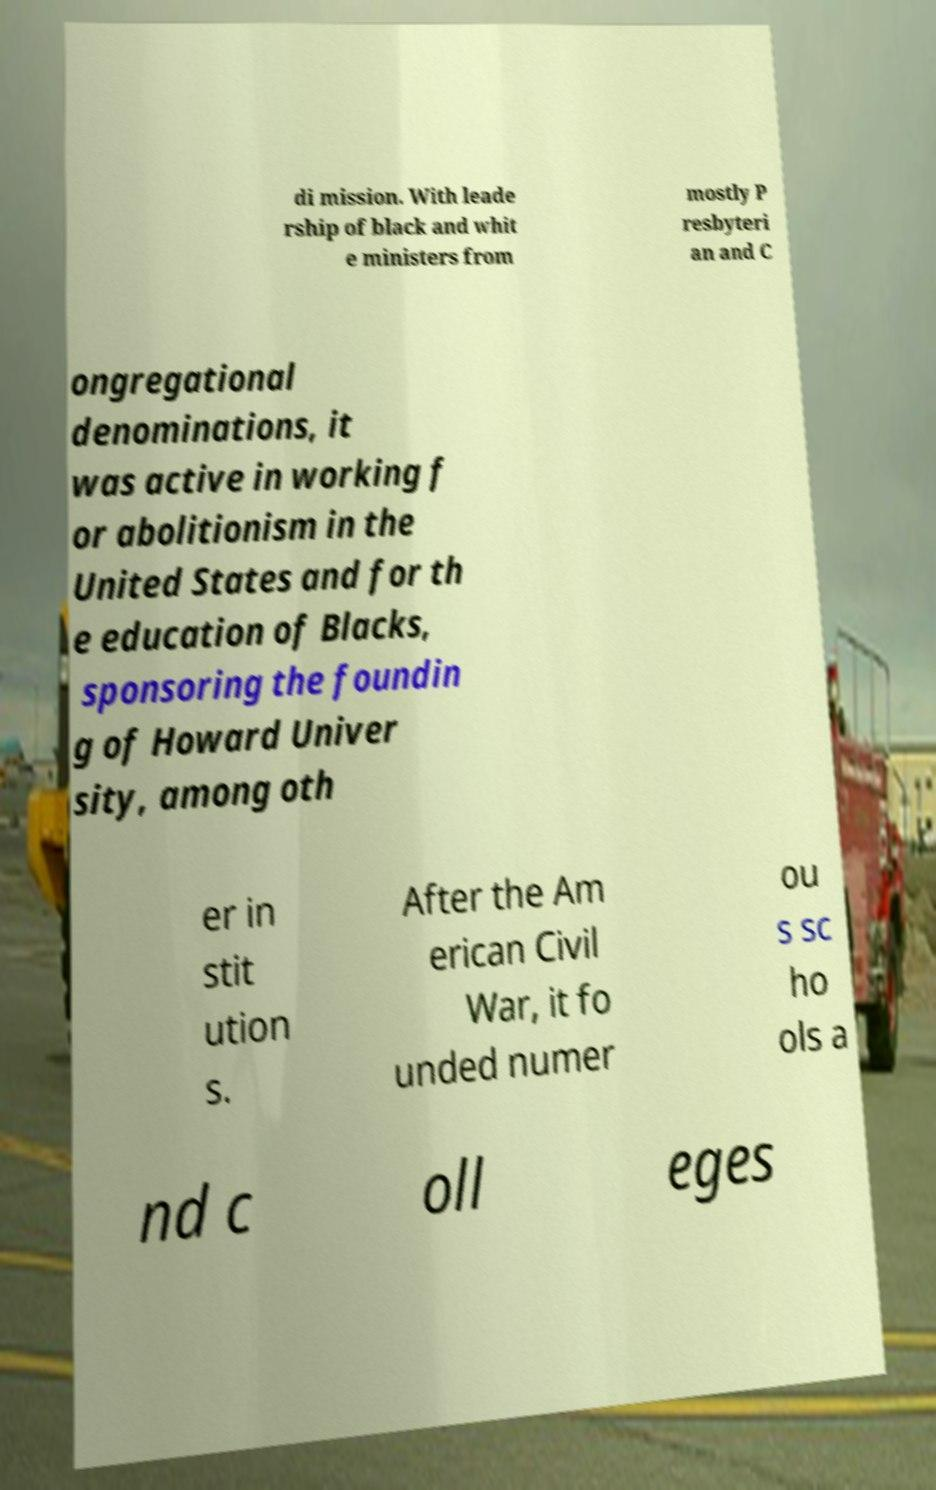Please identify and transcribe the text found in this image. di mission. With leade rship of black and whit e ministers from mostly P resbyteri an and C ongregational denominations, it was active in working f or abolitionism in the United States and for th e education of Blacks, sponsoring the foundin g of Howard Univer sity, among oth er in stit ution s. After the Am erican Civil War, it fo unded numer ou s sc ho ols a nd c oll eges 